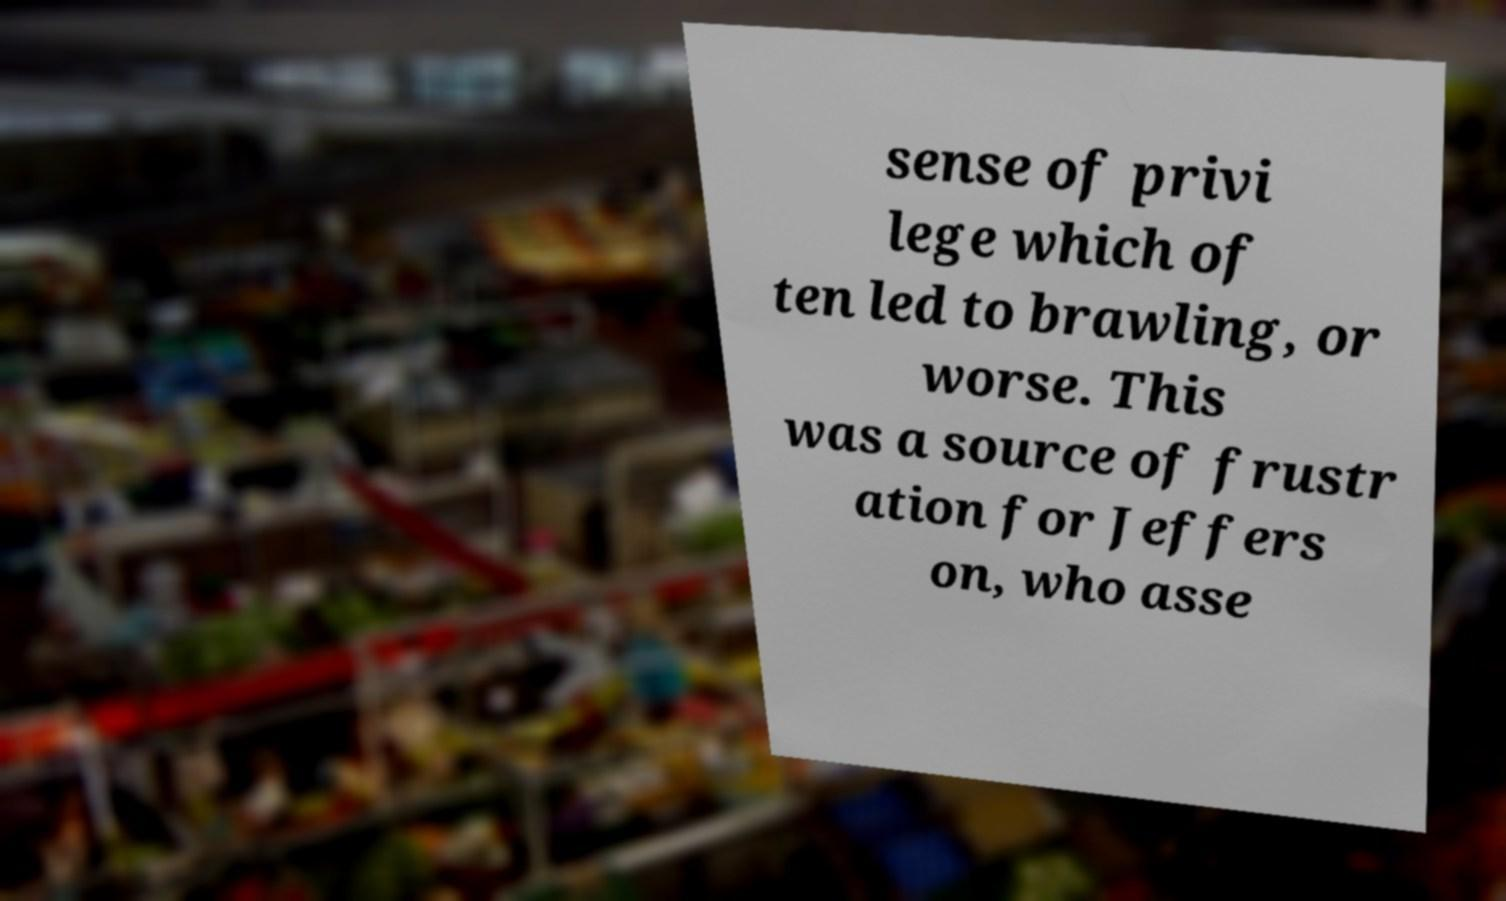Could you assist in decoding the text presented in this image and type it out clearly? sense of privi lege which of ten led to brawling, or worse. This was a source of frustr ation for Jeffers on, who asse 